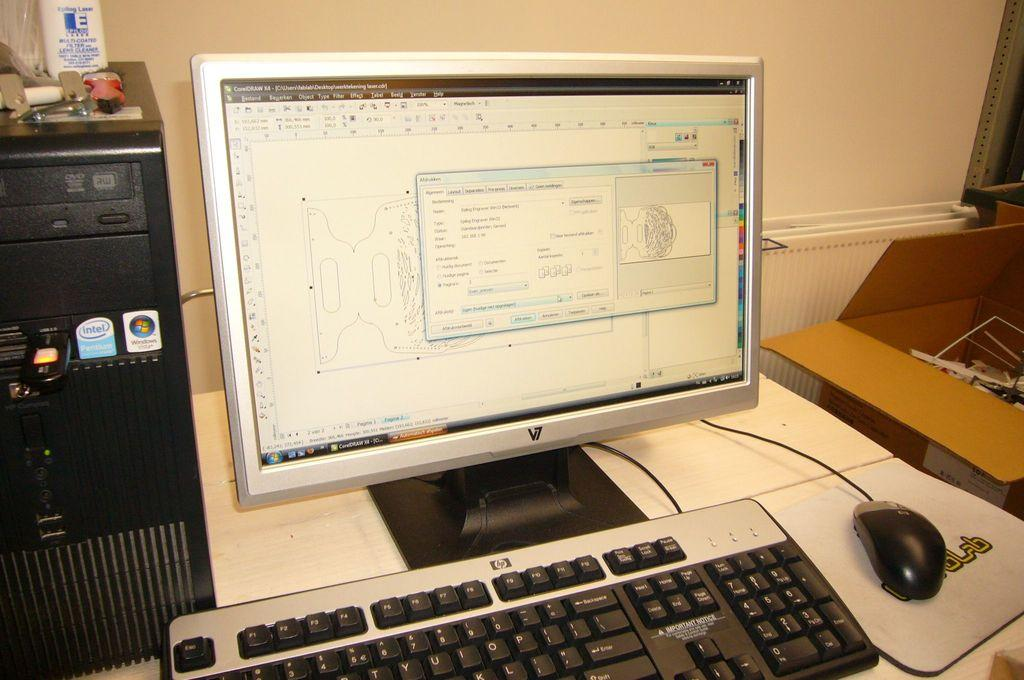<image>
Give a short and clear explanation of the subsequent image. The word intel can be seen on the computer tower. 